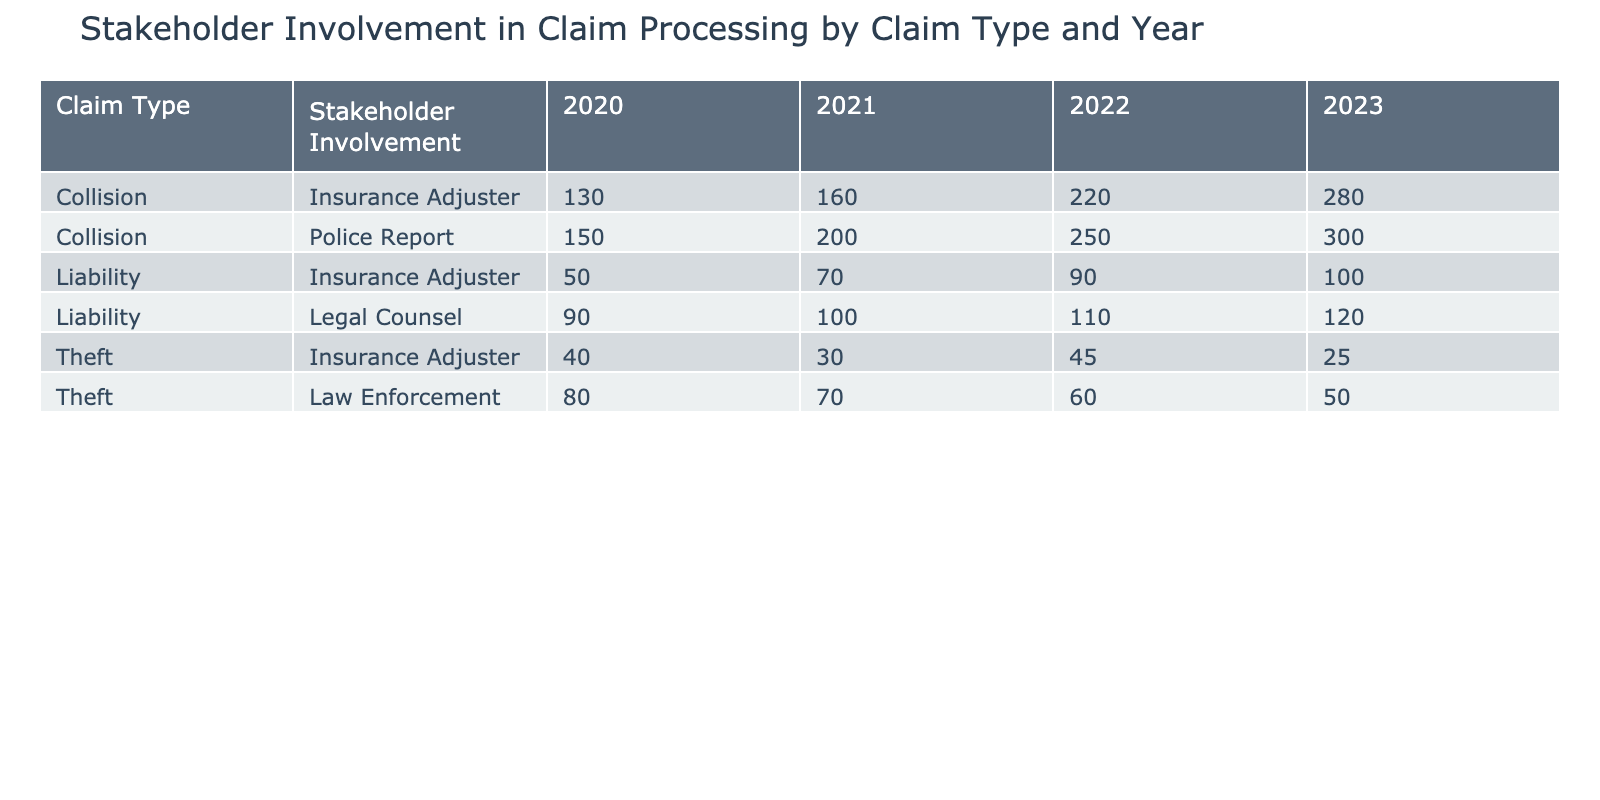What was the total number of collision claims for the year 2021? In the table, I locate the 'Collision' claim type for the year 2021. There are two entries for 'Collision' in 2021: one with 'Police Report' for 200 claims and one with 'Insurance Adjuster' for 160 claims. Summing these values gives 200 + 160 = 360.
Answer: 360 Which stakeholder had the lowest involvement for theft claims in 2022? I look for the 'Theft' claim type for the year 2022 in the table. There is one entry for 'Law Enforcement' with 60 claims and one for 'Insurance Adjuster' with 45 claims. Comparing these two values, 45 is the lowest.
Answer: Insurance Adjuster How did the number of collision claims in 2023 compare to 2020? I first find the 'Collision' claim type for the years 2020 and 2023 in the table. For 2020, there were 150 claims (Police Report) and 130 claims (Insurance Adjuster), summing to 280. In 2023, there were 300 claims (Police Report) and 280 claims (Insurance Adjuster), summing to 580. The difference is 580 - 280 = 300, meaning there are 300 more collision claims in 2023.
Answer: 300 more Is there any claim type for which 'Legal Counsel' had involvement in 2023? I search the table for entries under 'Legal Counsel' for the year 2023. There is one entry in the 'Liability' claim type for 120 claims. Since there is one entry, this confirms that 'Legal Counsel' was involved in 2023.
Answer: Yes What was the average number of claims for 'Liability' by 'Insurance Adjuster' across all years? I identify the 'Liability' claims processed by 'Insurance Adjuster' from the table: 50 (2020), 70 (2021), 90 (2022), and 100 (2023). I sum these values: 50 + 70 + 90 + 100 = 310. There are 4 entries, so I calculate the average as 310 / 4 = 77.5.
Answer: 77.5 In which year did the highest number of theft claims occur and what was the value? I check the table for 'Theft' claim types across the years. The numbers are 80 (2020), 70 (2021), 60 (2022), and 50 (2023). The highest is 80 in 2020.
Answer: 2020, 80 Which claim type had the most claims processed by insurance adjusters in 2022? I look for the totals for claims handled by 'Insurance Adjuster' in 2022: 'Collision' has 220 claims, 'Theft' has 45 claims, and 'Liability' has 90 claims. Comparing these numbers, 220 is the highest among them.
Answer: Collision Was there an increase in police report claims from 2020 to 2021 for collision types? The number of collision claims in 2020 (Police Report) was 150, and in 2021 (Police Report) it was 200. To verify the increase, I calculate 200 - 150 = 50, showing an increase of 50 claims from 2020 to 2021.
Answer: Yes How many total claims were processed by 'Insurance Adjuster' for 'Theft' across all years? I locate 'Theft' claims processed by 'Insurance Adjuster' in the table: 40 (2020), 30 (2021), 45 (2022), and 25 (2023). I sum these values: 40 + 30 + 45 + 25 = 140.
Answer: 140 What was the decline in the number of theft claims from 2020 to 2023? For 'Theft' claims processed, I find the numbers: 80 in 2020 and 50 in 2023. The decline is calculated as 80 - 50 = 30.
Answer: 30 